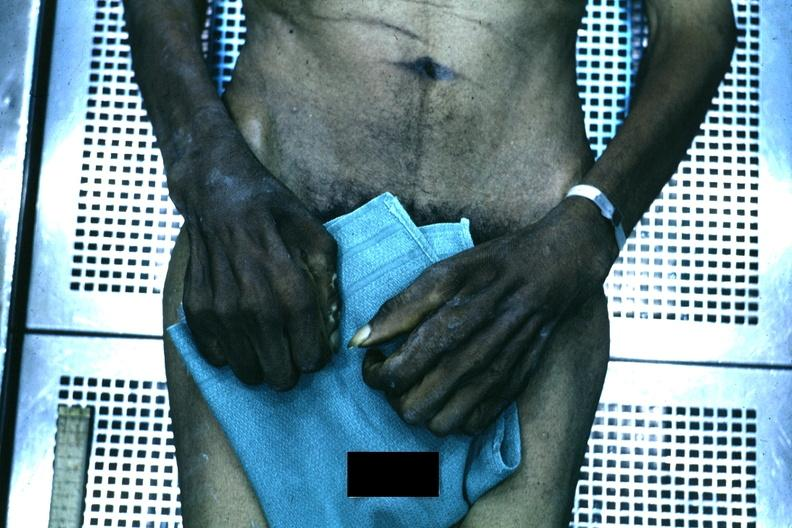what is good example of muscle atrophy said?
Answer the question using a single word or phrase. To be due to syringomyelia 